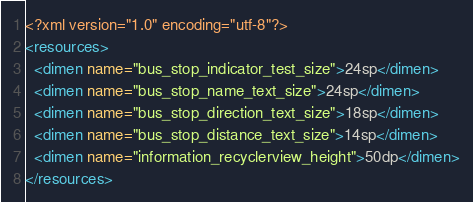<code> <loc_0><loc_0><loc_500><loc_500><_XML_><?xml version="1.0" encoding="utf-8"?>
<resources>
  <dimen name="bus_stop_indicator_test_size">24sp</dimen>
  <dimen name="bus_stop_name_text_size">24sp</dimen>
  <dimen name="bus_stop_direction_text_size">18sp</dimen>
  <dimen name="bus_stop_distance_text_size">14sp</dimen>
  <dimen name="information_recyclerview_height">50dp</dimen>
</resources></code> 